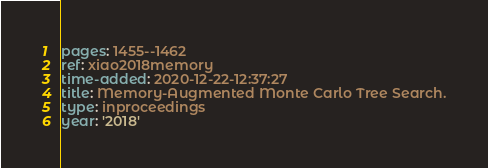Convert code to text. <code><loc_0><loc_0><loc_500><loc_500><_YAML_>pages: 1455--1462
ref: xiao2018memory
time-added: 2020-12-22-12:37:27
title: Memory-Augmented Monte Carlo Tree Search.
type: inproceedings
year: '2018'
</code> 